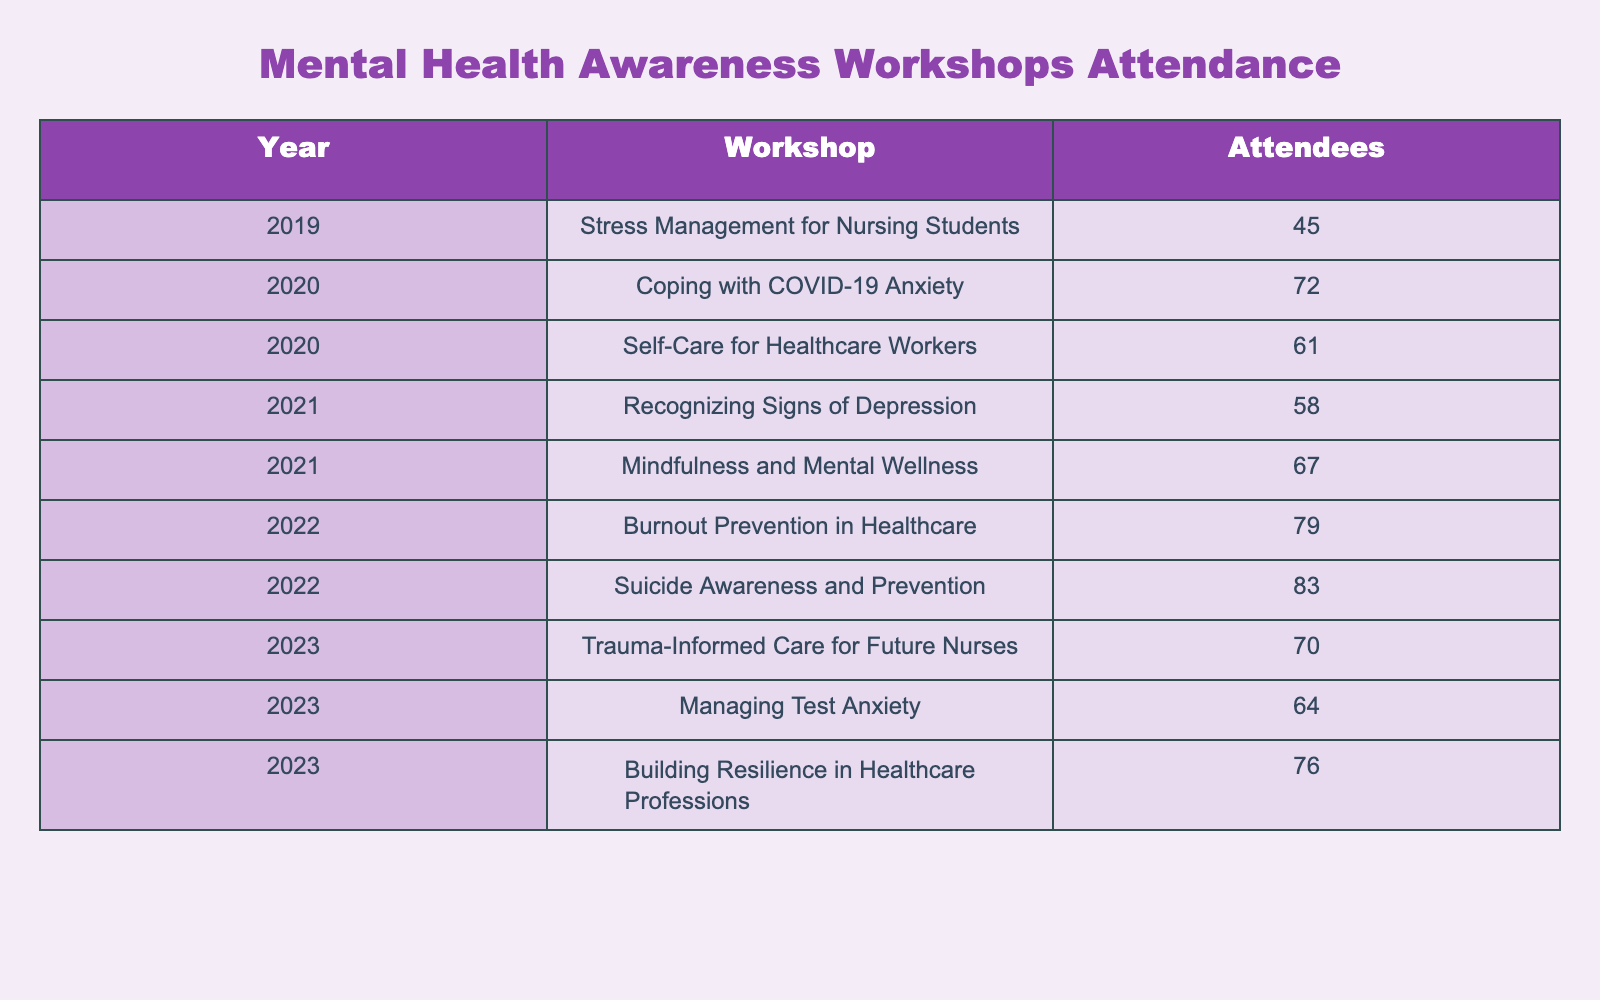What was the total number of attendees at the workshops in 2020? In 2020, there were two workshops: "Coping with COVID-19 Anxiety" with 72 attendees and "Self-Care for Healthcare Workers" with 61 attendees. Adding these together, 72 + 61 = 133.
Answer: 133 Which workshop had the highest attendance? The workshop titled "Suicide Awareness and Prevention" in 2022 had the highest attendance with 83 attendees, compared to the other workshops listed.
Answer: 83 Did more attendees participate in "Recognizing Signs of Depression" or "Mindfulness and Mental Wellness"? The workshop "Recognizing Signs of Depression" had 58 attendees, while "Mindfulness and Mental Wellness" had 67 attendees. Since 67 is greater than 58, there were more attendees in "Mindfulness and Mental Wellness".
Answer: Yes What is the average attendance for workshops held in 2023? In 2023, there were three workshops: "Trauma-Informed Care for Future Nurses" (70 attendees), "Managing Test Anxiety" (64 attendees), and "Building Resilience in Healthcare Professions" (76 attendees). The total attendance is 70 + 64 + 76 = 210, and the average is 210 divided by 3, which equals 70.
Answer: 70 How many attendees were there in total for workshops in the year 2021? In 2021, there were two workshops: "Recognizing Signs of Depression" with 58 attendees and "Mindfulness and Mental Wellness" with 67 attendees. Adding these two values gives a total of 58 + 67 = 125 attendees.
Answer: 125 Identify the year with the least number of attendees across workshops. The year 2019 had only one workshop, "Stress Management for Nursing Students," which had 45 attendees. Since all other years had more than one workshop and more attendees, 2019 is the year with the least total attendance.
Answer: 2019 What is the difference in attendance between the most and least attended workshops? The workshop with the most attendees is "Suicide Awareness and Prevention" (83 attendees), and the one with the least is "Stress Management for Nursing Students" (45 attendees). The difference is 83 - 45 = 38.
Answer: 38 Which year saw an overall increase in attendance compared to the previous year? In 2020, the workshops' total attendance was 133. In 2021, it was 125, which is a decrease. In 2022, the total was 162, an increase from 125. Thus, attendance increased in 2022 compared to 2021.
Answer: 2022 